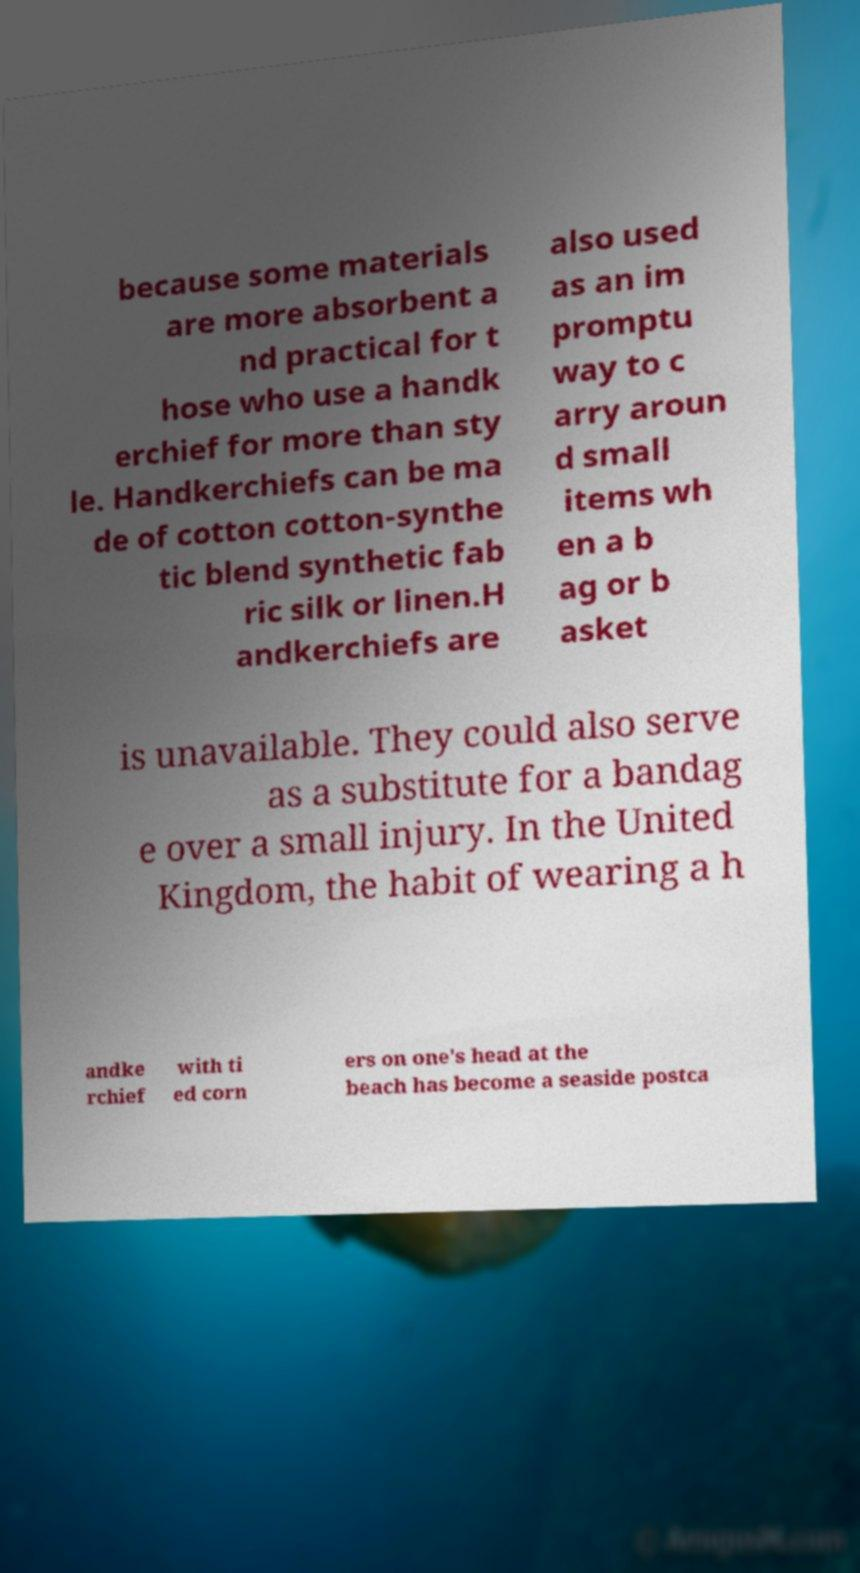I need the written content from this picture converted into text. Can you do that? because some materials are more absorbent a nd practical for t hose who use a handk erchief for more than sty le. Handkerchiefs can be ma de of cotton cotton-synthe tic blend synthetic fab ric silk or linen.H andkerchiefs are also used as an im promptu way to c arry aroun d small items wh en a b ag or b asket is unavailable. They could also serve as a substitute for a bandag e over a small injury. In the United Kingdom, the habit of wearing a h andke rchief with ti ed corn ers on one's head at the beach has become a seaside postca 